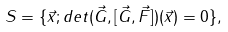<formula> <loc_0><loc_0><loc_500><loc_500>S = \{ \vec { x } ; d e t ( \vec { G } , [ \vec { G } , \vec { F } ] ) ( \vec { x } ) = 0 \} ,</formula> 